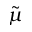Convert formula to latex. <formula><loc_0><loc_0><loc_500><loc_500>\tilde { \mu }</formula> 